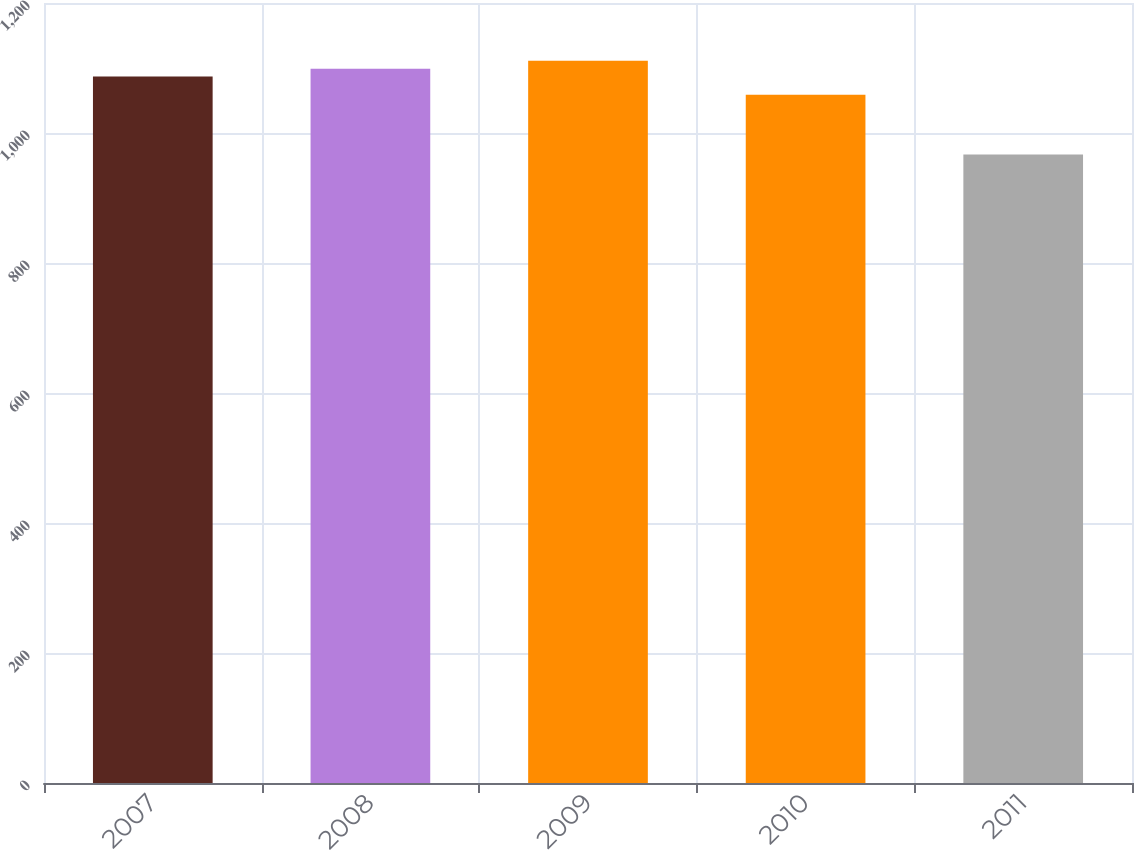<chart> <loc_0><loc_0><loc_500><loc_500><bar_chart><fcel>2007<fcel>2008<fcel>2009<fcel>2010<fcel>2011<nl><fcel>1087<fcel>1099<fcel>1111<fcel>1059<fcel>967<nl></chart> 